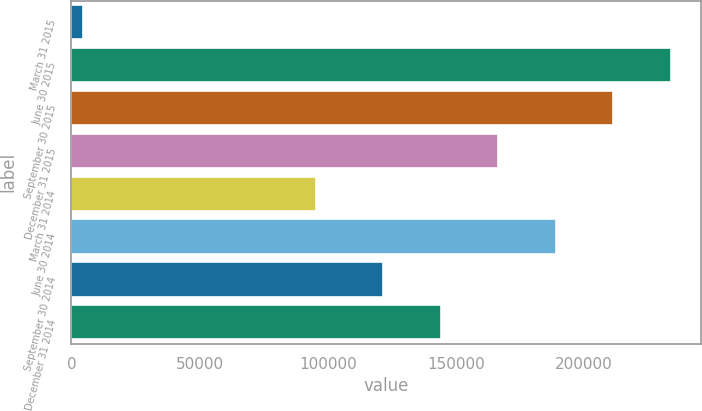<chart> <loc_0><loc_0><loc_500><loc_500><bar_chart><fcel>March 31 2015<fcel>June 30 2015<fcel>September 30 2015<fcel>December 31 2015<fcel>March 31 2014<fcel>June 30 2014<fcel>September 30 2014<fcel>December 31 2014<nl><fcel>4414<fcel>233895<fcel>211436<fcel>166518<fcel>95250<fcel>188977<fcel>121600<fcel>144059<nl></chart> 